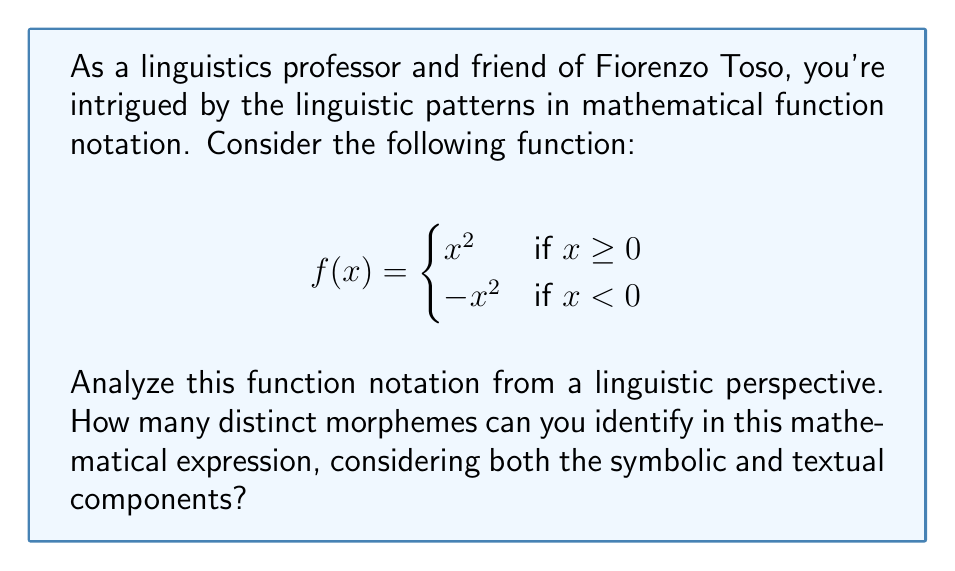Help me with this question. Let's break down the function notation into its linguistic components:

1. Function name: $f$ (1 morpheme)
2. Input variable: $x$ (1 morpheme)
3. Equality symbol: $=$ (1 morpheme)
4. Curly braces: $\{$ and $\}$ (1 morpheme, as they function as a single unit)
5. Squaring operation: $^2$ (1 morpheme)
6. Negative sign: $-$ (1 morpheme)
7. Comparison operators: $\geq$ and $<$ (2 morphemes)
8. Number: $0$ (1 morpheme)
9. Textual components:
   - "if" (1 morpheme)

In total, we have 10 distinct morphemes.

Note: While "if" appears twice, we count it as one distinct morpheme. The expression $x^2$ is considered as two morphemes ($x$ and $^2$) since they can function independently in other contexts.
Answer: 10 morphemes 